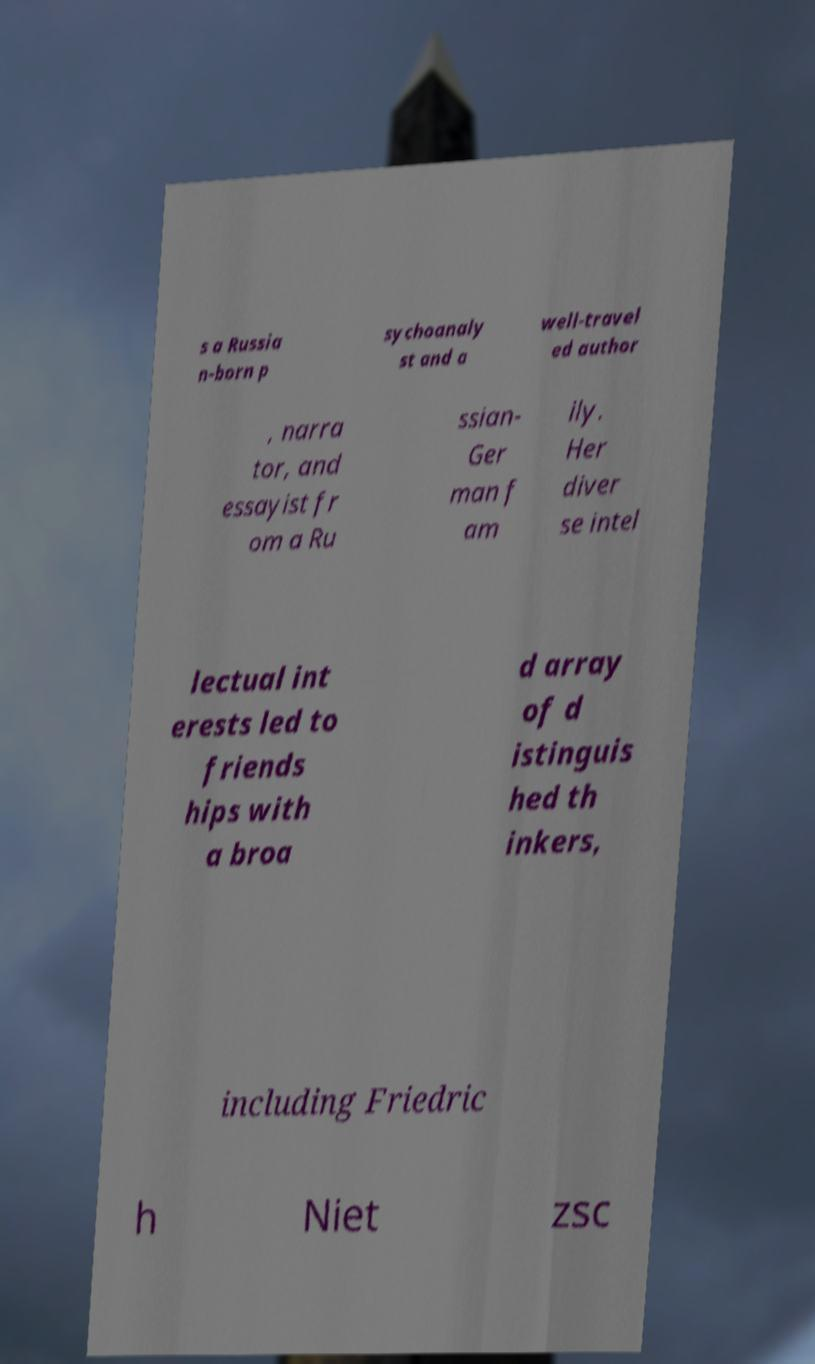Could you assist in decoding the text presented in this image and type it out clearly? s a Russia n-born p sychoanaly st and a well-travel ed author , narra tor, and essayist fr om a Ru ssian- Ger man f am ily. Her diver se intel lectual int erests led to friends hips with a broa d array of d istinguis hed th inkers, including Friedric h Niet zsc 